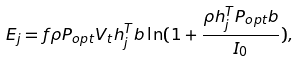<formula> <loc_0><loc_0><loc_500><loc_500>E _ { j } = f \rho P _ { o p t } V _ { t } h _ { j } ^ { T } b \ln ( 1 + \frac { \rho h _ { j } ^ { T } P _ { o p t } b } { I _ { 0 } } ) ,</formula> 